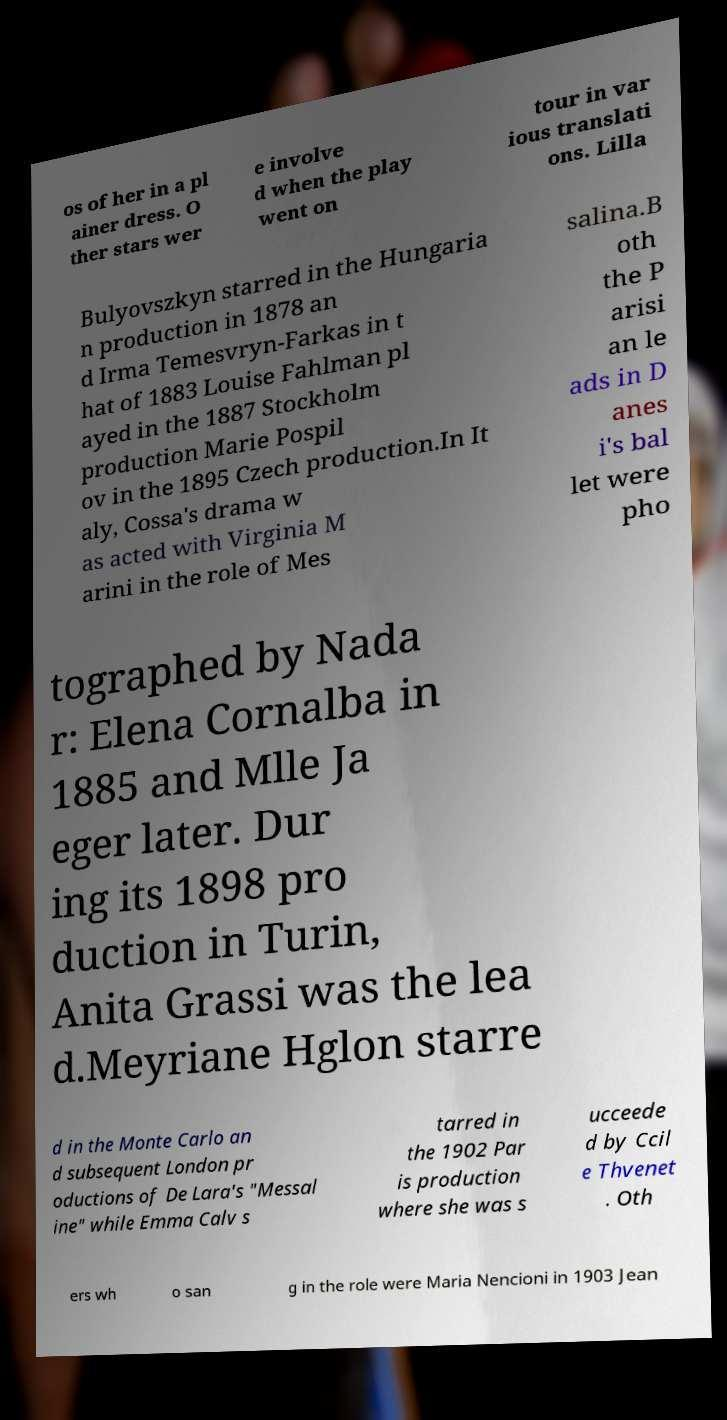Can you read and provide the text displayed in the image?This photo seems to have some interesting text. Can you extract and type it out for me? os of her in a pl ainer dress. O ther stars wer e involve d when the play went on tour in var ious translati ons. Lilla Bulyovszkyn starred in the Hungaria n production in 1878 an d Irma Temesvryn-Farkas in t hat of 1883 Louise Fahlman pl ayed in the 1887 Stockholm production Marie Pospil ov in the 1895 Czech production.In It aly, Cossa's drama w as acted with Virginia M arini in the role of Mes salina.B oth the P arisi an le ads in D anes i's bal let were pho tographed by Nada r: Elena Cornalba in 1885 and Mlle Ja eger later. Dur ing its 1898 pro duction in Turin, Anita Grassi was the lea d.Meyriane Hglon starre d in the Monte Carlo an d subsequent London pr oductions of De Lara's "Messal ine" while Emma Calv s tarred in the 1902 Par is production where she was s ucceede d by Ccil e Thvenet . Oth ers wh o san g in the role were Maria Nencioni in 1903 Jean 